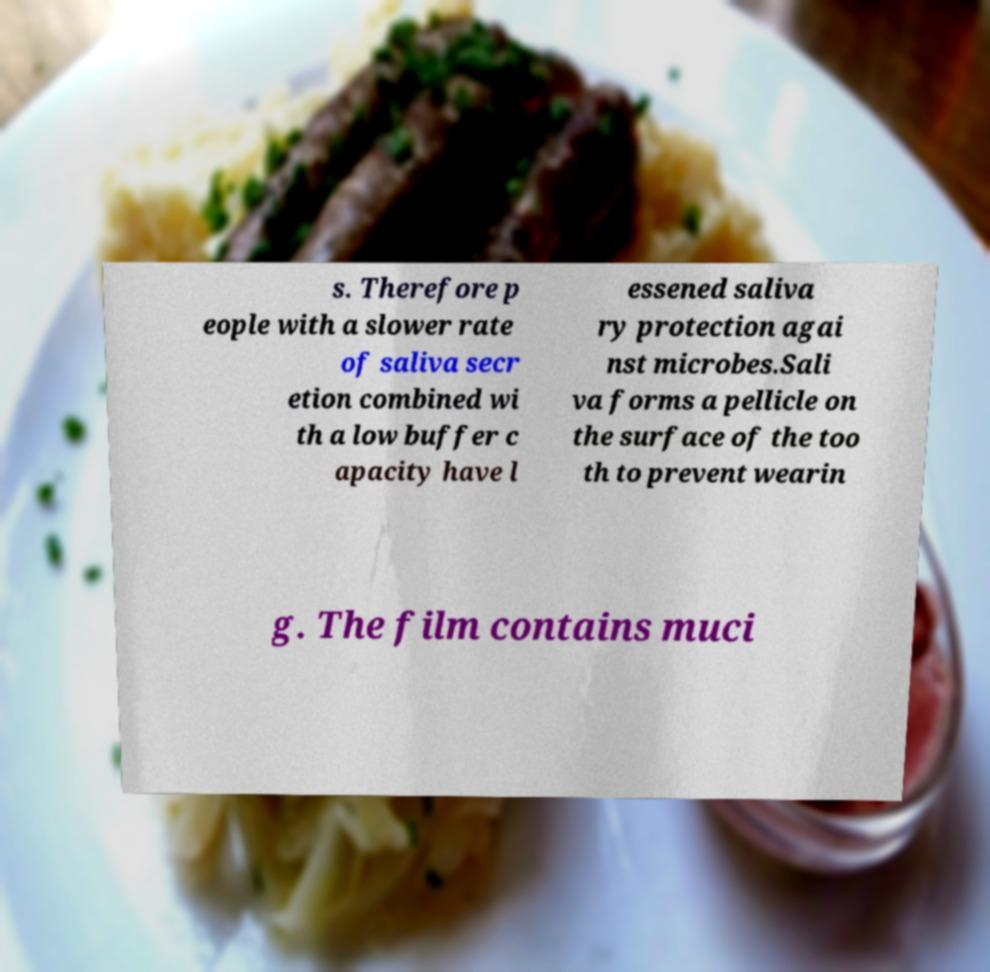Can you read and provide the text displayed in the image?This photo seems to have some interesting text. Can you extract and type it out for me? s. Therefore p eople with a slower rate of saliva secr etion combined wi th a low buffer c apacity have l essened saliva ry protection agai nst microbes.Sali va forms a pellicle on the surface of the too th to prevent wearin g. The film contains muci 